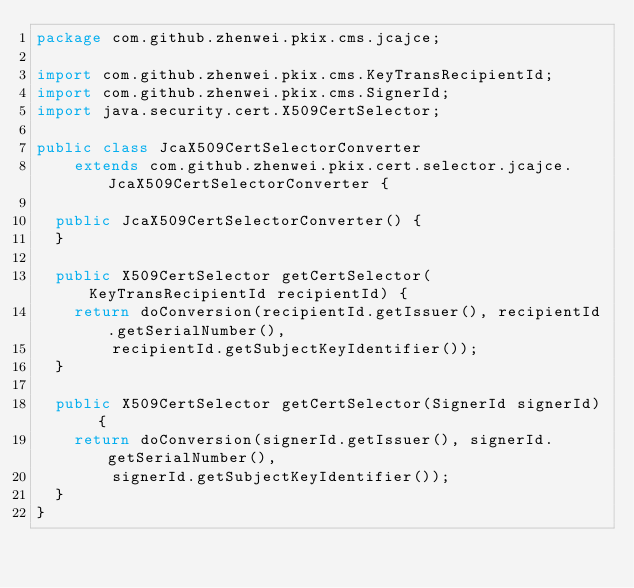Convert code to text. <code><loc_0><loc_0><loc_500><loc_500><_Java_>package com.github.zhenwei.pkix.cms.jcajce;

import com.github.zhenwei.pkix.cms.KeyTransRecipientId;
import com.github.zhenwei.pkix.cms.SignerId;
import java.security.cert.X509CertSelector;

public class JcaX509CertSelectorConverter
    extends com.github.zhenwei.pkix.cert.selector.jcajce.JcaX509CertSelectorConverter {

  public JcaX509CertSelectorConverter() {
  }

  public X509CertSelector getCertSelector(KeyTransRecipientId recipientId) {
    return doConversion(recipientId.getIssuer(), recipientId.getSerialNumber(),
        recipientId.getSubjectKeyIdentifier());
  }

  public X509CertSelector getCertSelector(SignerId signerId) {
    return doConversion(signerId.getIssuer(), signerId.getSerialNumber(),
        signerId.getSubjectKeyIdentifier());
  }
}</code> 